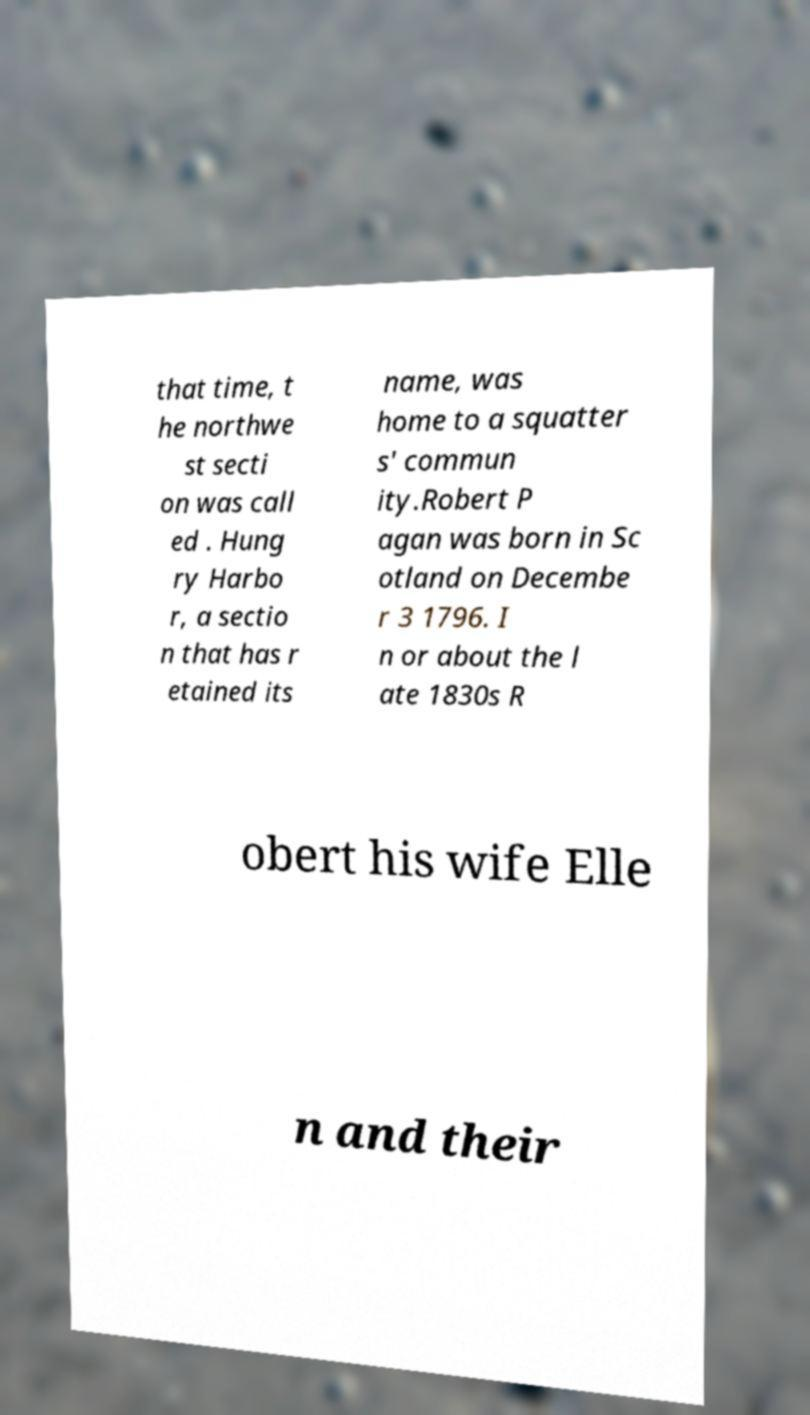Can you accurately transcribe the text from the provided image for me? that time, t he northwe st secti on was call ed . Hung ry Harbo r, a sectio n that has r etained its name, was home to a squatter s' commun ity.Robert P agan was born in Sc otland on Decembe r 3 1796. I n or about the l ate 1830s R obert his wife Elle n and their 